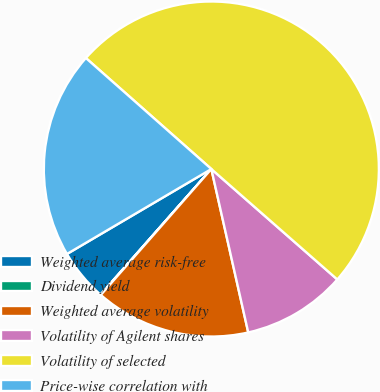Convert chart to OTSL. <chart><loc_0><loc_0><loc_500><loc_500><pie_chart><fcel>Weighted average risk-free<fcel>Dividend yield<fcel>Weighted average volatility<fcel>Volatility of Agilent shares<fcel>Volatility of selected<fcel>Price-wise correlation with<nl><fcel>5.03%<fcel>0.04%<fcel>15.0%<fcel>10.01%<fcel>49.93%<fcel>19.99%<nl></chart> 